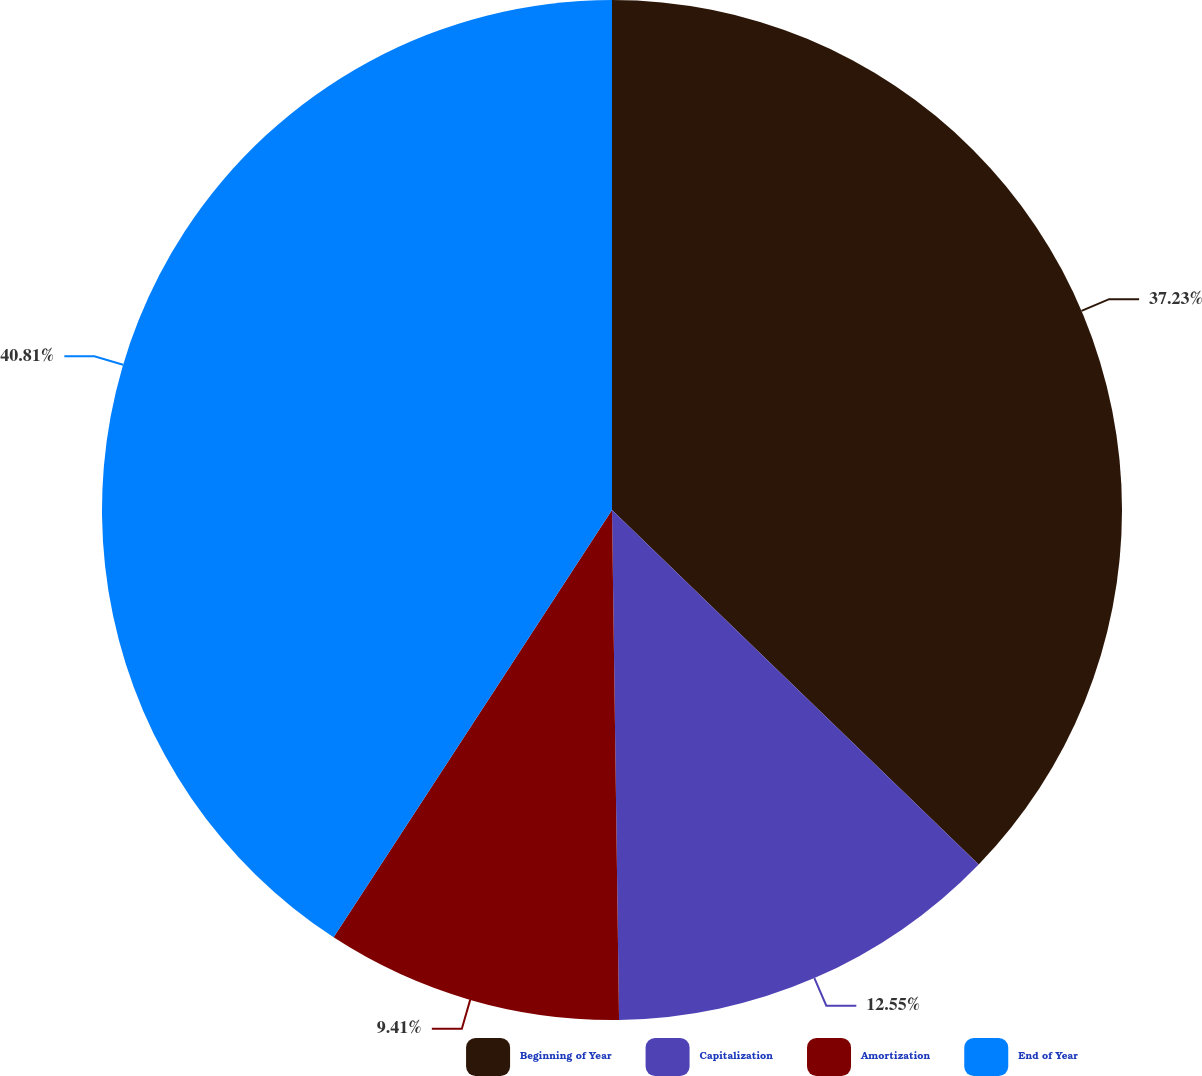<chart> <loc_0><loc_0><loc_500><loc_500><pie_chart><fcel>Beginning of Year<fcel>Capitalization<fcel>Amortization<fcel>End of Year<nl><fcel>37.23%<fcel>12.55%<fcel>9.41%<fcel>40.81%<nl></chart> 